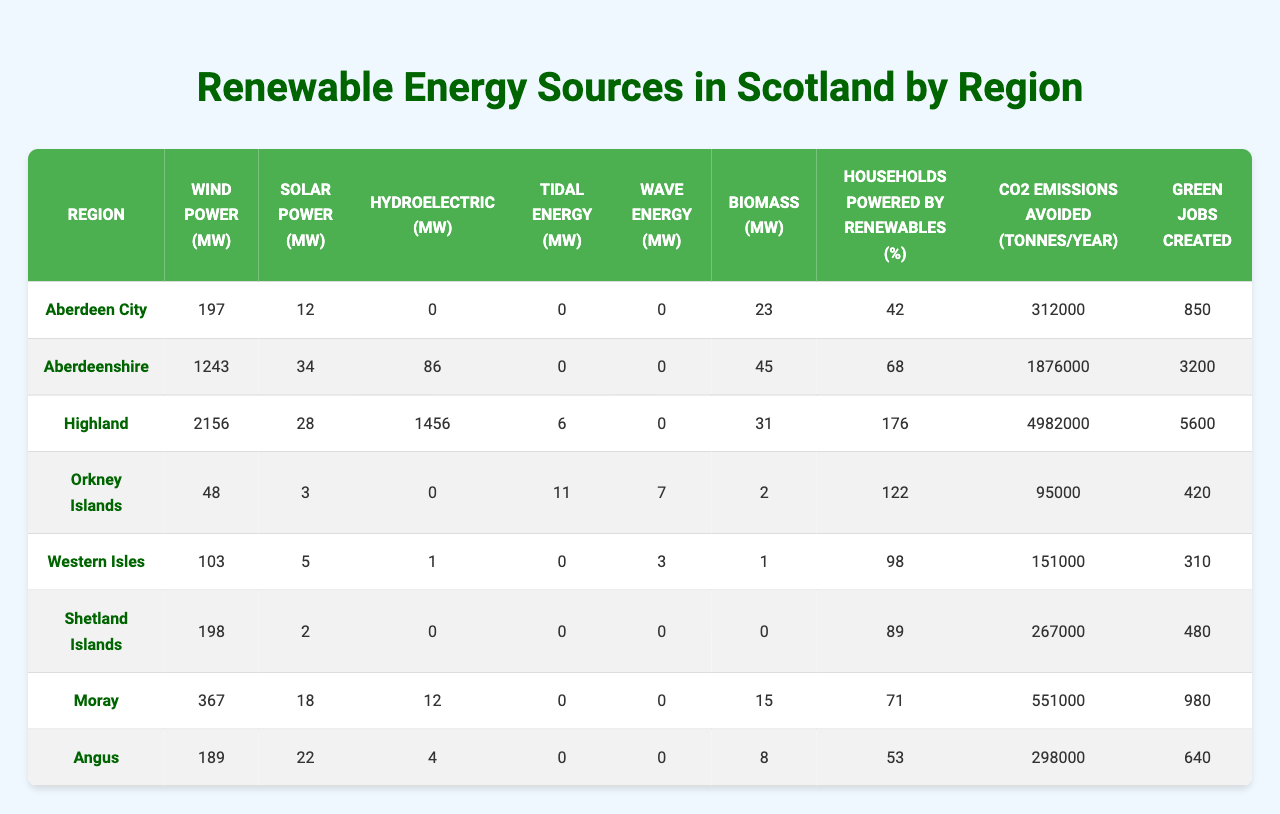What region has the highest wind power capacity? Looking at the "Wind Power (MW)" column, Aberdeenshire has the highest value at 1243 MW.
Answer: Aberdeenshire What is the total solar power capacity across all regions? To find the total solar power capacity, sum all values from the "Solar Power (MW)" column: 12 + 34 + 28 + 3 + 5 + 2 + 18 + 22 = 124 MW.
Answer: 124 Which region has the least biomass power? In the "Biomass (MW)" column, Shetland Islands has the least amount at 0 MW.
Answer: Shetland Islands Is it true that the Highland region has more hydroelectric power than wind power? The "Hydroelectric (MW)" value for Highland is 1456 MW, which is greater than its wind power value of 2156 MW. Therefore, the statement is false.
Answer: False What is the average percentage of households powered by renewables across all regions? The percentages are 42, 68, 176, 122, 98, 89, 71, and 53. Summing these gives 719, and averaging (719/8) gives about 89.875%.
Answer: 89.88 What region avoided the most CO2 emissions? Referring to the "CO2 Emissions Avoided (tonnes/year)" column, Highland avoided the most CO2 emissions at 4982000 tonnes.
Answer: Highland How much more wind power does Moray have compared to the Orkney Islands? Wind power in Moray is 367 MW, and for Orkney Islands, it is 48 MW. The difference is 367 - 48 = 319 MW.
Answer: 319 MW Which region has the highest number of green jobs created? Looking at the "Green Jobs Created" column, Highland again has the highest with 5600 jobs.
Answer: Highland How many regions have tidal energy production? Tidal energy is present in the regions with values greater than 0, specifically Highland (6 MW) and Orkney Islands (11 MW), totaling 2 regions.
Answer: 2 What percentage of households in the Western Isles are powered by renewables compared to Shetland Islands? The Western Isles have 98%, while Shetland Islands have 89%. Western Isles has 9% more than Shetland Islands.
Answer: 9% 